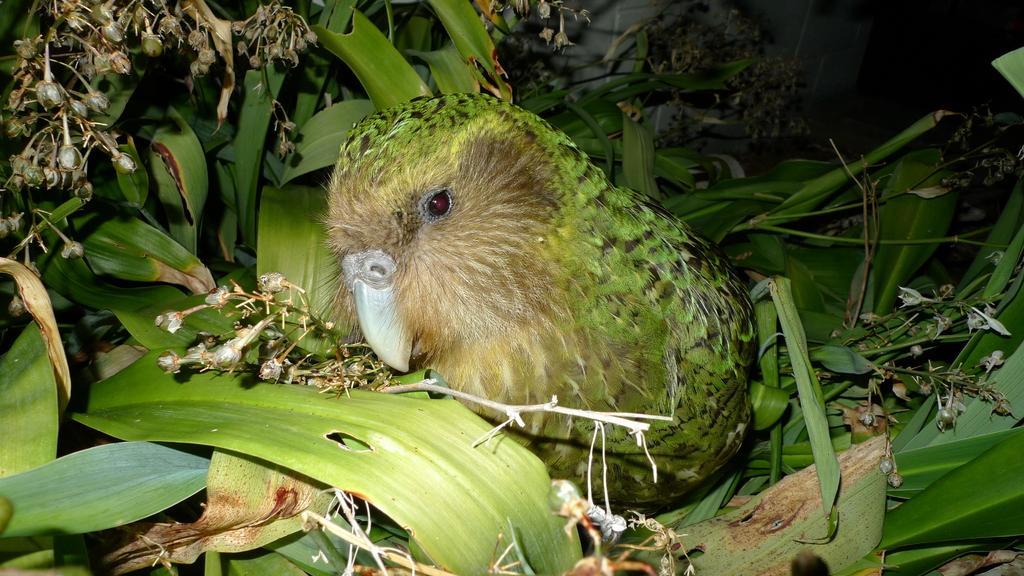Describe this image in one or two sentences. In this image, I can see a bird, which is green in color. I think these are the plants with leaves. I can see the bunch of flower buds. 